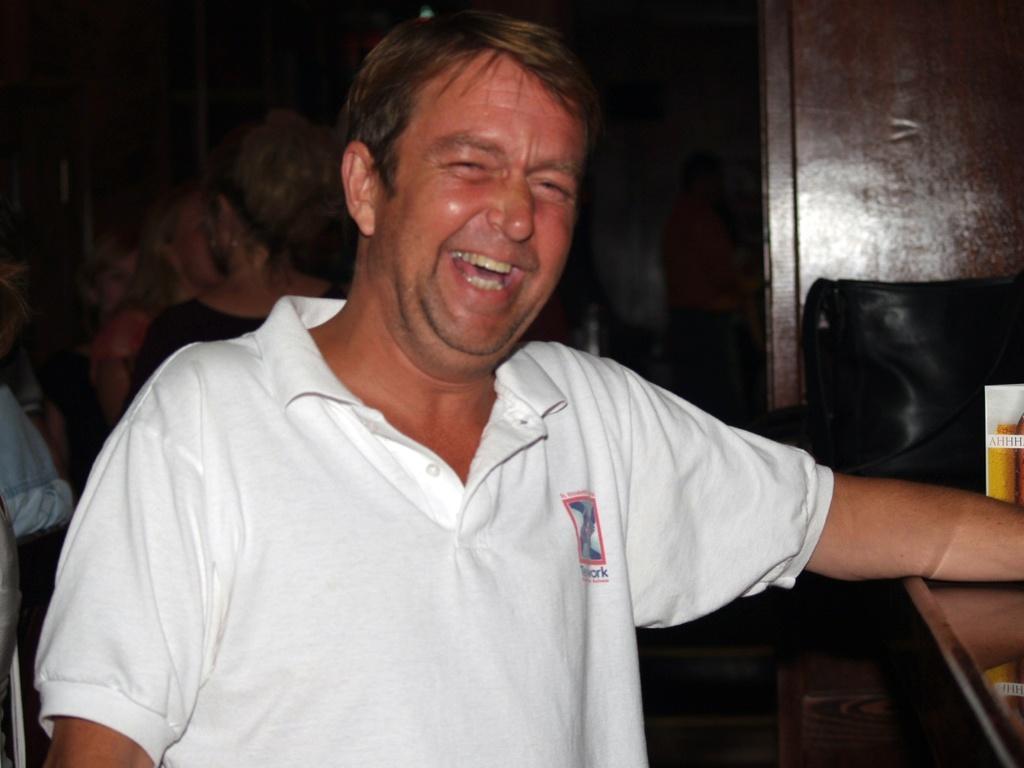Can you describe this image briefly? In the center of the image, we can see a man laughing and in the background, there are some people and we can see a bag and some other objects on the stand. 